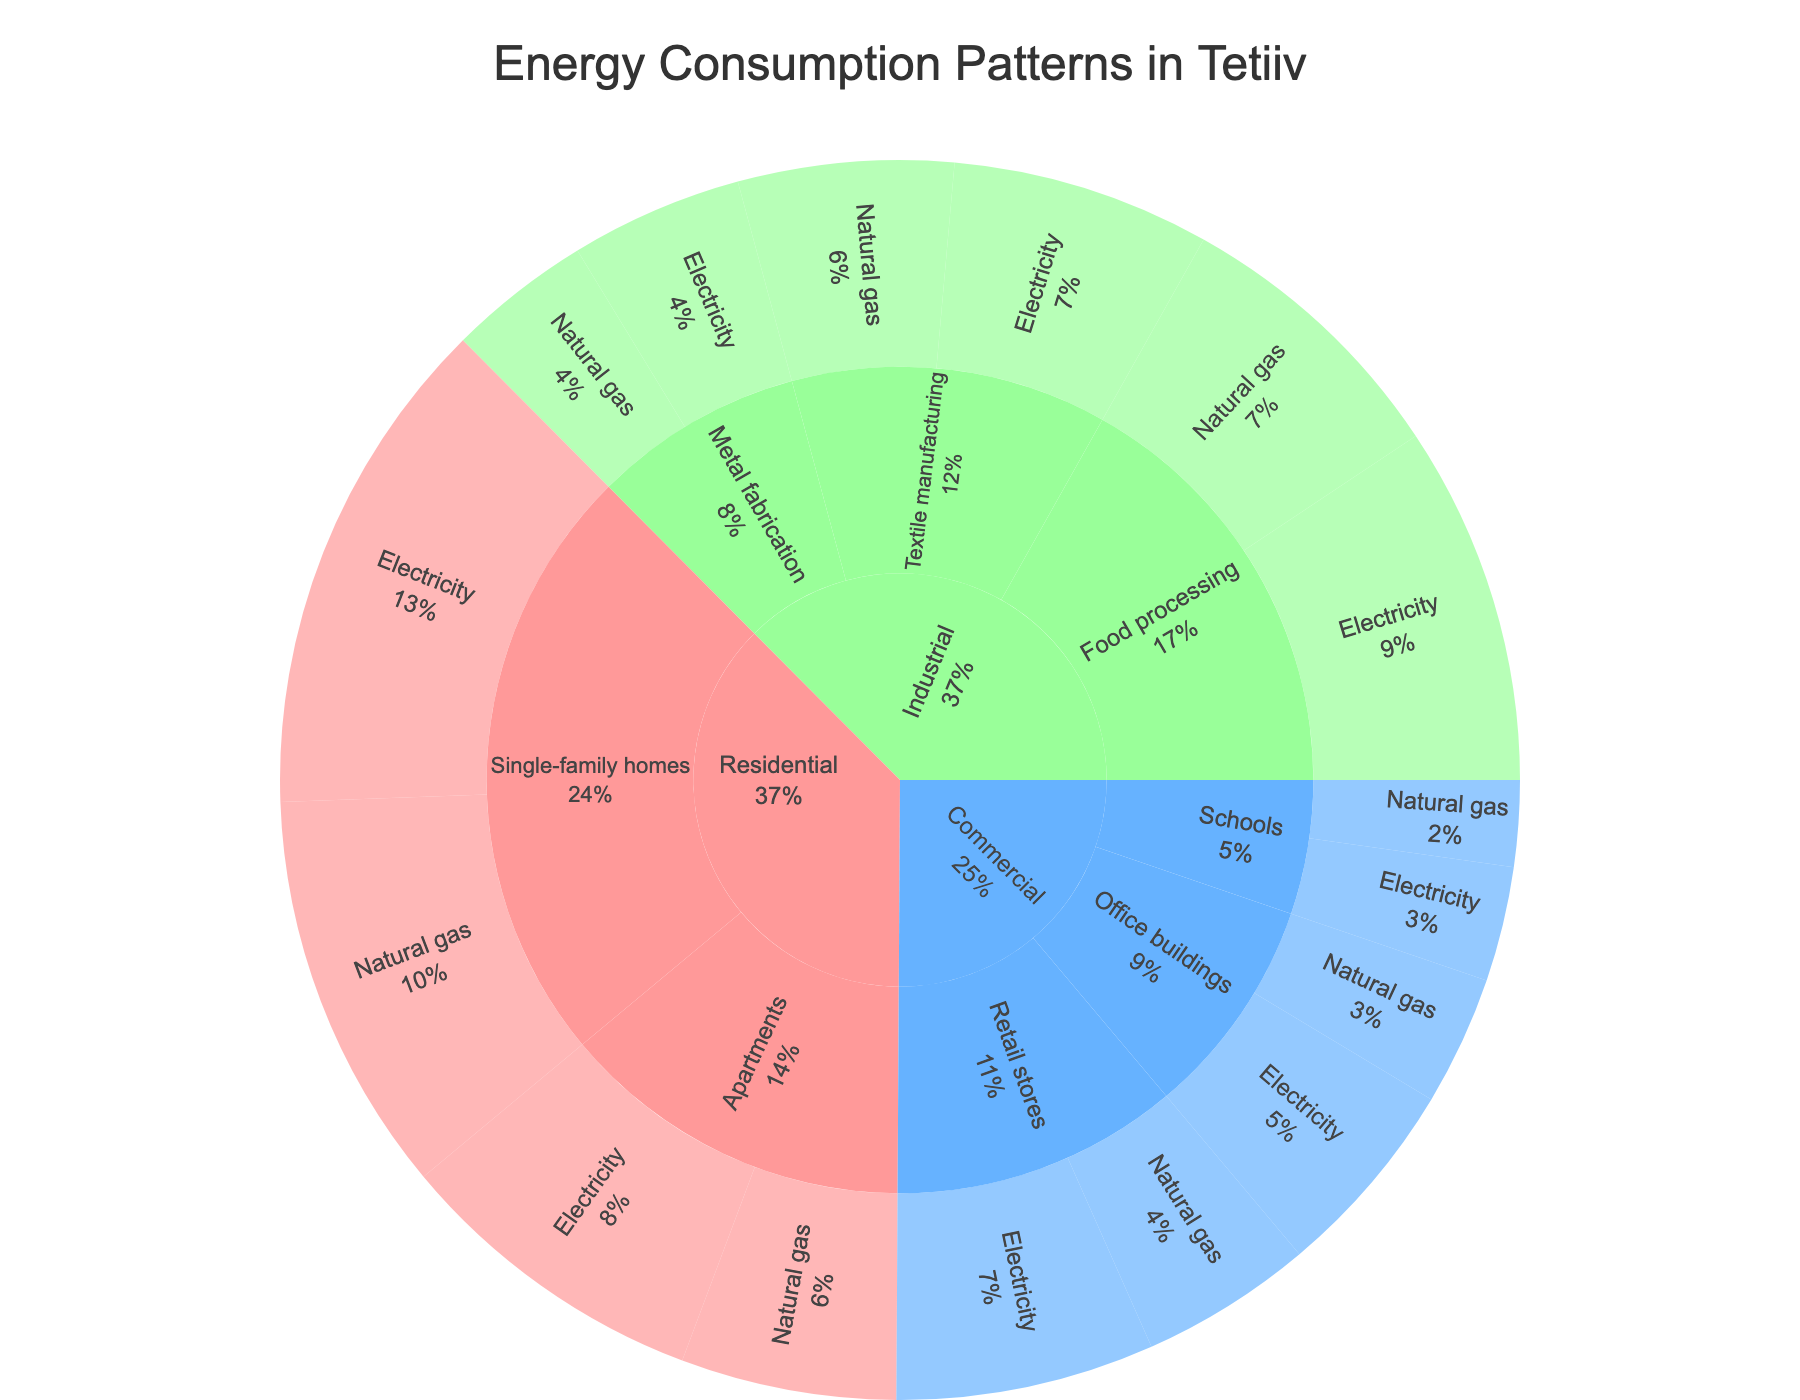What are the main sectors visualized in the Sunburst plot? The main sectors are the first level of the Sunburst plot, directly stemming from the plot's central point. In this plot, the main sectors are Residential, Commercial, and Industrial.
Answer: Residential, Commercial, Industrial Which energy source has the highest consumption in the Residential sector? The sectors under the "Residential" category can be visually inspected to identify the energy source with the highest consumption. The longest arc in the Residential sector for energy sources shows that Electricity is the highest.
Answer: Electricity How much total energy consumption is attributed to the Commercial sector? Add up all the consumption values of the subsectors and energy sources under the Commercial sector: 18 (Retail stores electricity) + 12 (Retail stores natural gas) + 14 (Office buildings electricity) + 9 (Office buildings natural gas) + 8 (Schools electricity) + 6 (Schools natural gas) = 67.
Answer: 67 What is the combined energy consumption for Single-family homes in the Residential sector? Sum the consumption values for electricity and natural gas in Single-family homes: 35 (Electricity) + 28 (Natural gas) = 63.
Answer: 63 Which sector has a higher natural gas consumption, Industrial or Commercial? Compare the total natural gas consumption within the Industrial and Commercial sectors. Industrial: 20 (Food processing) + 15 (Textile manufacturing) + 10 (Metal fabrication) = 45. Commercial: 12 (Retail stores) + 9 (Office buildings) + 6 (Schools) = 27.
Answer: Industrial What percentage of the total energy consumption does the Textile manufacturing subsector represent? Sum the entire consumption values to find the total, then determine the percentage for Textile manufacturing. Total: 35+28+22+15+18+12+14+9+8+6+25+20+18+15+12+10 = 267. Textile manufacturing total: 18 (electricity) + 15 (natural gas) = 33. Percentage: (33/267) * 100 = 12.36%.
Answer: 12.36% How does the energy consumption of Food processing in the Industrial sector compare to Single-family homes in the Residential sector? Compare the total consumptions: Food processing (25 electricity + 20 natural gas) = 45, Single-family homes (35 electricity + 28 natural gas) = 63.
Answer: Single-family homes have higher consumption What is the energy source with the lowest overall consumption in the dataset? Identify the energy source by comparing all individual consumption values across sectors and subsectors. The lowest value in the dataset is 6 (Natural gas for Schools).
Answer: Natural gas in Schools Between Metal fabrication and Apartments, which one has higher total energy consumption? Compare the combined consumption values for both categories: Metal fabrication (12 electricity + 10 natural gas) = 22, Apartments (22 electricity + 15 natural gas) = 37.
Answer: Apartments What is the ratio of electricity consumption to natural gas consumption in the Commercial sector? Calculate the total consumption for each energy source in the Commercial sector: Electricity: 18+14+8 = 40, Natural gas: 12+9+6 = 27. Then find the ratio: 40/27 ≈ 1.48.
Answer: 1.48 